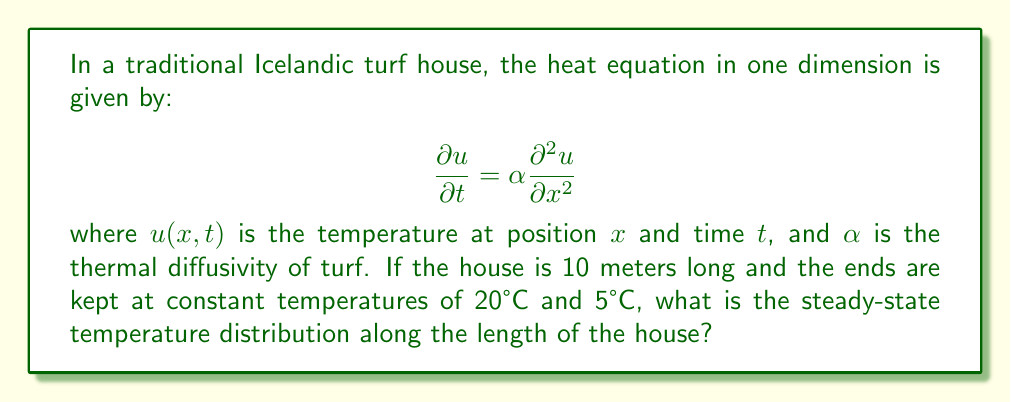Could you help me with this problem? To solve this problem, we need to follow these steps:

1) For the steady-state solution, the temperature doesn't change with time. So, $\frac{\partial u}{\partial t} = 0$. This reduces our heat equation to:

   $$0 = \alpha \frac{\partial^2 u}{\partial x^2}$$

2) Integrating twice with respect to $x$:

   $$u(x) = Ax + B$$

   where $A$ and $B$ are constants we need to determine.

3) We can use the boundary conditions to find $A$ and $B$:
   - At $x = 0$, $u(0) = 20°C$
   - At $x = 10$, $u(10) = 5°C$

4) Applying these conditions:

   $20 = B$
   $5 = 10A + B$

5) Solving these equations:

   $B = 20$
   $A = -1.5$

6) Therefore, the steady-state temperature distribution is:

   $$u(x) = -1.5x + 20$$

This linear function describes how the temperature changes along the length of the house, from 20°C at one end to 5°C at the other.
Answer: $u(x) = -1.5x + 20$ 